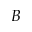<formula> <loc_0><loc_0><loc_500><loc_500>B</formula> 